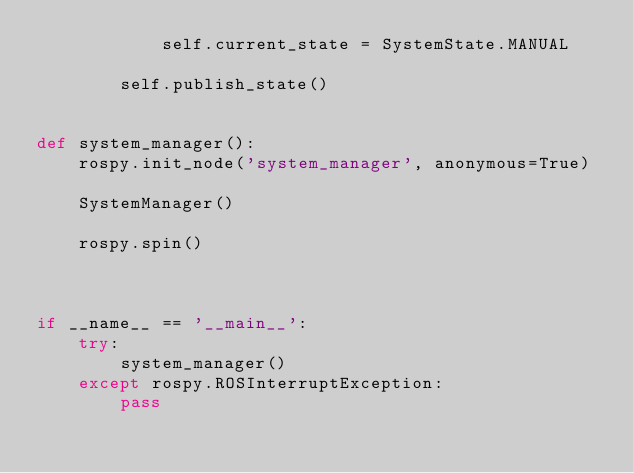Convert code to text. <code><loc_0><loc_0><loc_500><loc_500><_Python_>            self.current_state = SystemState.MANUAL

        self.publish_state()


def system_manager():
    rospy.init_node('system_manager', anonymous=True)

    SystemManager()

    rospy.spin()



if __name__ == '__main__':
    try:
        system_manager()
    except rospy.ROSInterruptException:
        pass

</code> 